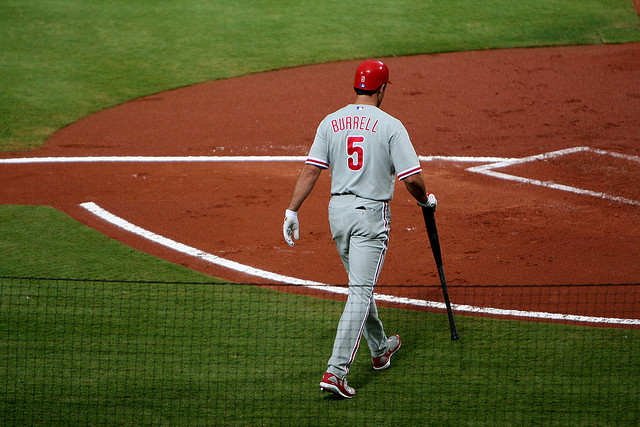Please extract the text content from this image. BURRELL 5 